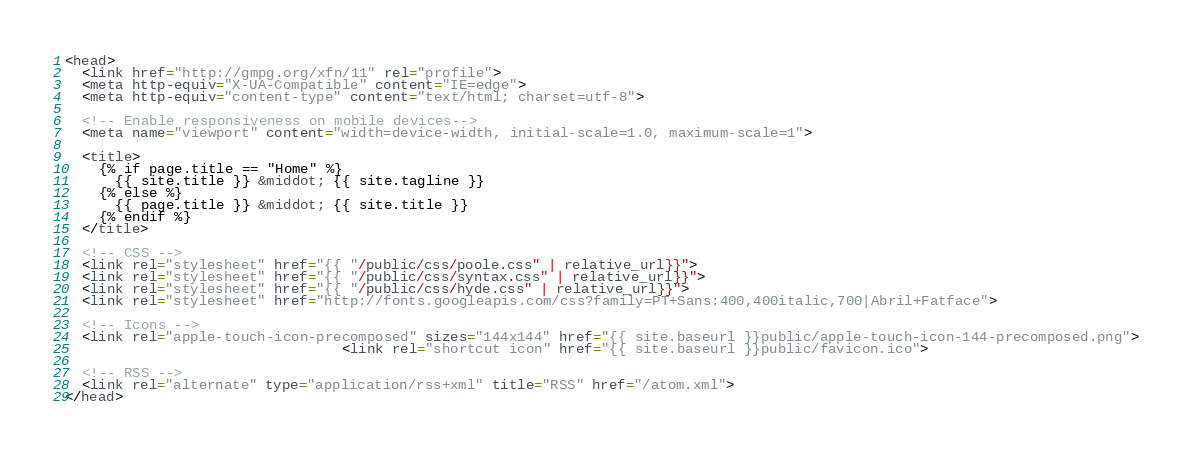Convert code to text. <code><loc_0><loc_0><loc_500><loc_500><_HTML_><head>
  <link href="http://gmpg.org/xfn/11" rel="profile">
  <meta http-equiv="X-UA-Compatible" content="IE=edge">
  <meta http-equiv="content-type" content="text/html; charset=utf-8">

  <!-- Enable responsiveness on mobile devices-->
  <meta name="viewport" content="width=device-width, initial-scale=1.0, maximum-scale=1">

  <title>
    {% if page.title == "Home" %}
      {{ site.title }} &middot; {{ site.tagline }}
    {% else %}
      {{ page.title }} &middot; {{ site.title }}
    {% endif %}
  </title>

  <!-- CSS -->
  <link rel="stylesheet" href="{{ "/public/css/poole.css" | relative_url}}">
  <link rel="stylesheet" href="{{ "/public/css/syntax.css" | relative_url}}">
  <link rel="stylesheet" href="{{ "/public/css/hyde.css" | relative_url}}">
  <link rel="stylesheet" href="http://fonts.googleapis.com/css?family=PT+Sans:400,400italic,700|Abril+Fatface">

  <!-- Icons -->
  <link rel="apple-touch-icon-precomposed" sizes="144x144" href="{{ site.baseurl }}public/apple-touch-icon-144-precomposed.png">
                                 <link rel="shortcut icon" href="{{ site.baseurl }}public/favicon.ico">

  <!-- RSS -->
  <link rel="alternate" type="application/rss+xml" title="RSS" href="/atom.xml">
</head>
</code> 